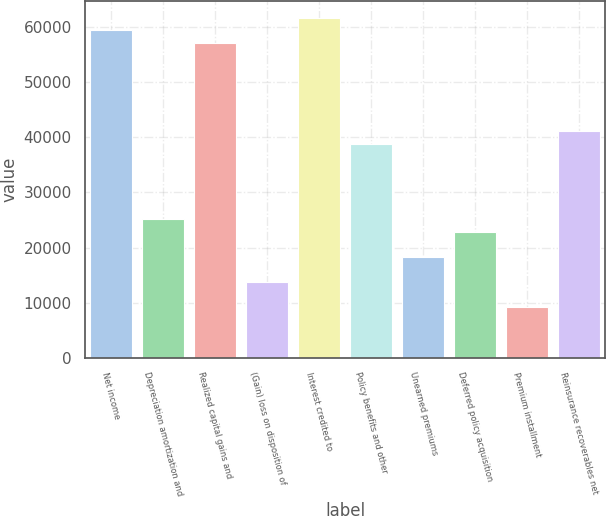Convert chart. <chart><loc_0><loc_0><loc_500><loc_500><bar_chart><fcel>Net income<fcel>Depreciation amortization and<fcel>Realized capital gains and<fcel>(Gain) loss on disposition of<fcel>Interest credited to<fcel>Policy benefits and other<fcel>Unearned premiums<fcel>Deferred policy acquisition<fcel>Premium installment<fcel>Reinsurance recoverables net<nl><fcel>59487.4<fcel>25168.9<fcel>57199.5<fcel>13729.4<fcel>61775.3<fcel>38896.3<fcel>18305.2<fcel>22881<fcel>9153.6<fcel>41184.2<nl></chart> 